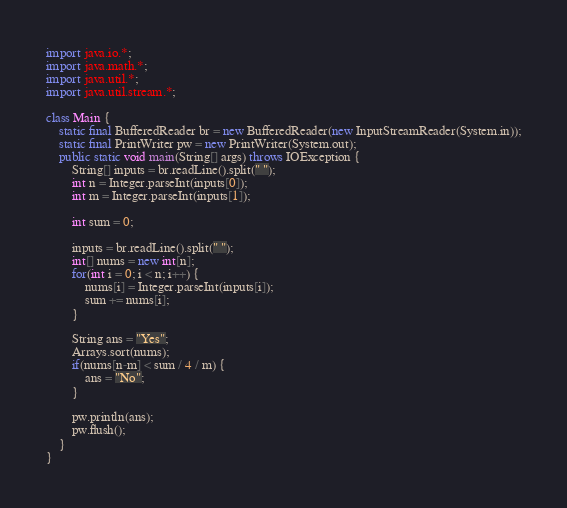<code> <loc_0><loc_0><loc_500><loc_500><_Java_>import java.io.*;
import java.math.*;
import java.util.*;
import java.util.stream.*;

class Main {
    static final BufferedReader br = new BufferedReader(new InputStreamReader(System.in));
    static final PrintWriter pw = new PrintWriter(System.out);
    public static void main(String[] args) throws IOException {
        String[] inputs = br.readLine().split(" ");
        int n = Integer.parseInt(inputs[0]);
        int m = Integer.parseInt(inputs[1]);

        int sum = 0;

        inputs = br.readLine().split(" ");
        int[] nums = new int[n];
        for(int i = 0; i < n; i++) {
            nums[i] = Integer.parseInt(inputs[i]);
            sum += nums[i];
        }

        String ans = "Yes";
        Arrays.sort(nums);
        if(nums[n-m] < sum / 4 / m) {
            ans = "No";
        }

        pw.println(ans);
        pw.flush();
    }
}
</code> 